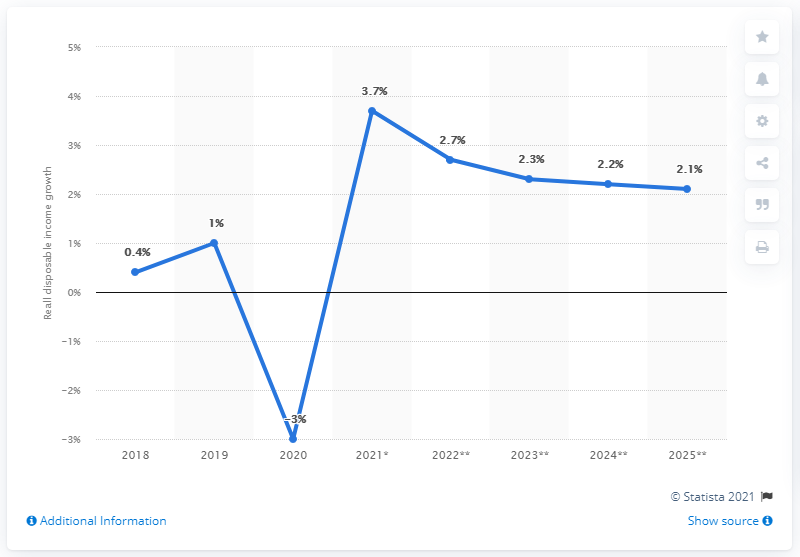Specify some key components in this picture. The income growth forecast for Russia in 2020 was 3.7%. According to projections, the income growth in Russia was expected to reach 2.1% in 2025. 